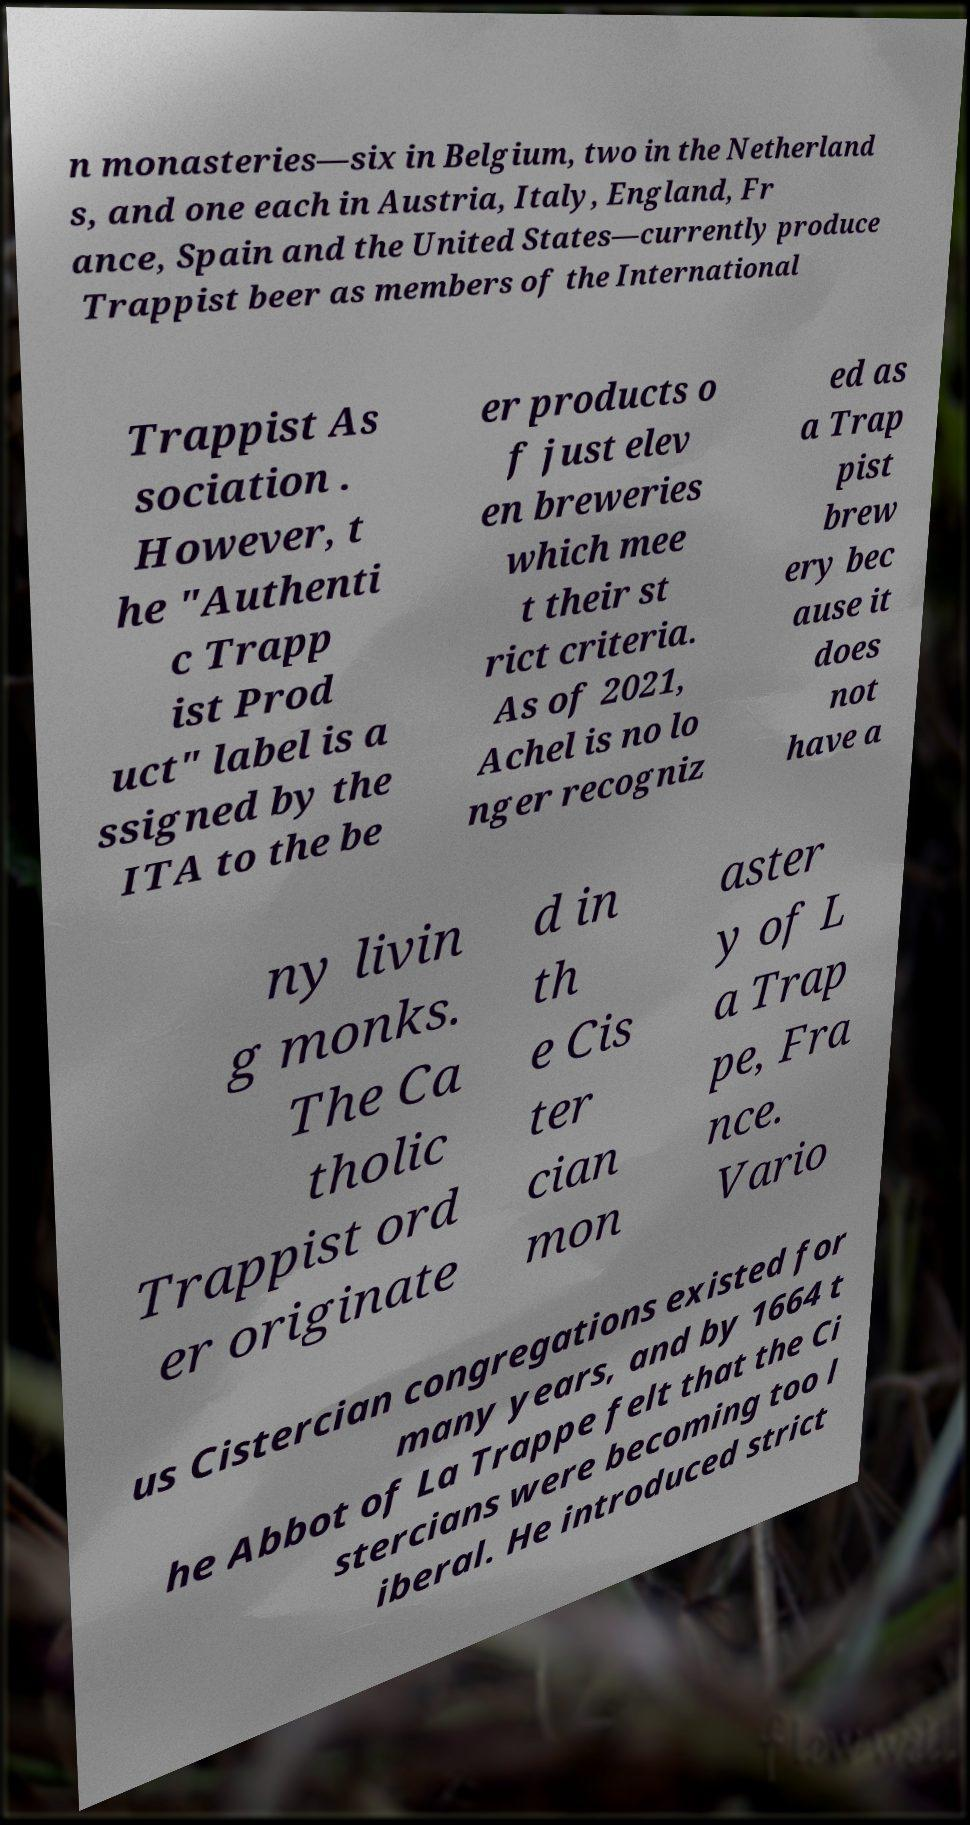I need the written content from this picture converted into text. Can you do that? n monasteries—six in Belgium, two in the Netherland s, and one each in Austria, Italy, England, Fr ance, Spain and the United States—currently produce Trappist beer as members of the International Trappist As sociation . However, t he "Authenti c Trapp ist Prod uct" label is a ssigned by the ITA to the be er products o f just elev en breweries which mee t their st rict criteria. As of 2021, Achel is no lo nger recogniz ed as a Trap pist brew ery bec ause it does not have a ny livin g monks. The Ca tholic Trappist ord er originate d in th e Cis ter cian mon aster y of L a Trap pe, Fra nce. Vario us Cistercian congregations existed for many years, and by 1664 t he Abbot of La Trappe felt that the Ci stercians were becoming too l iberal. He introduced strict 